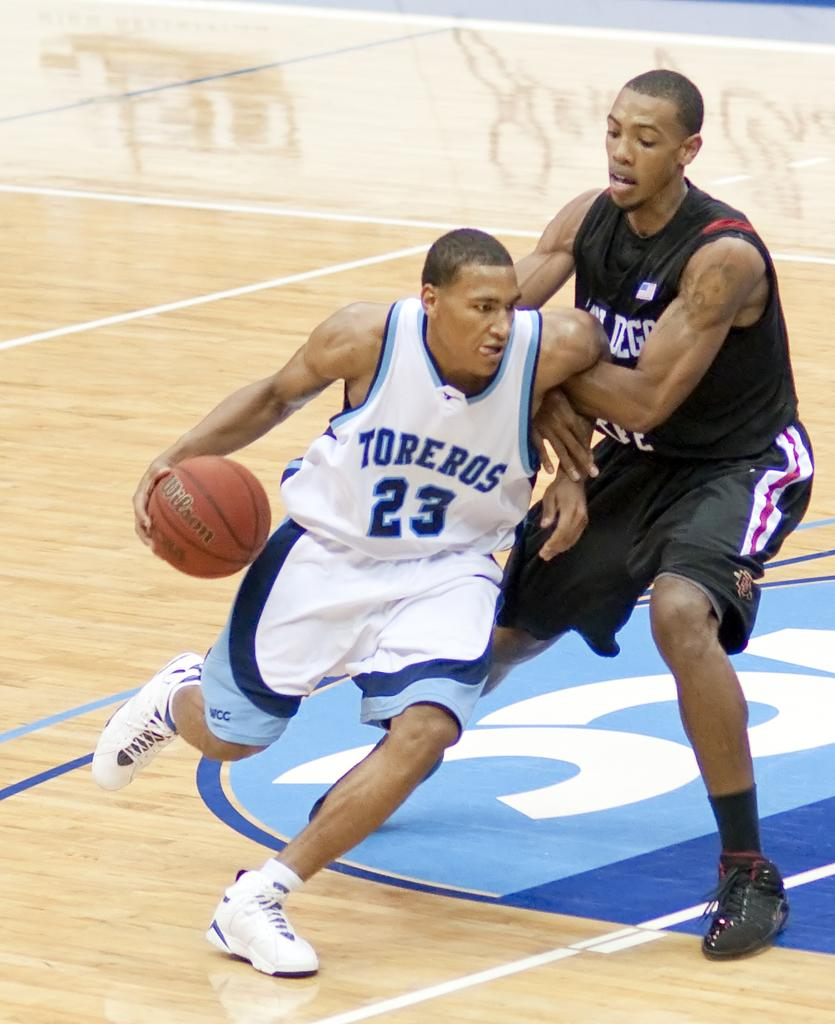<image>
Create a compact narrative representing the image presented. Toreros attempts to get past the enemy teams defense while playing basketball. 